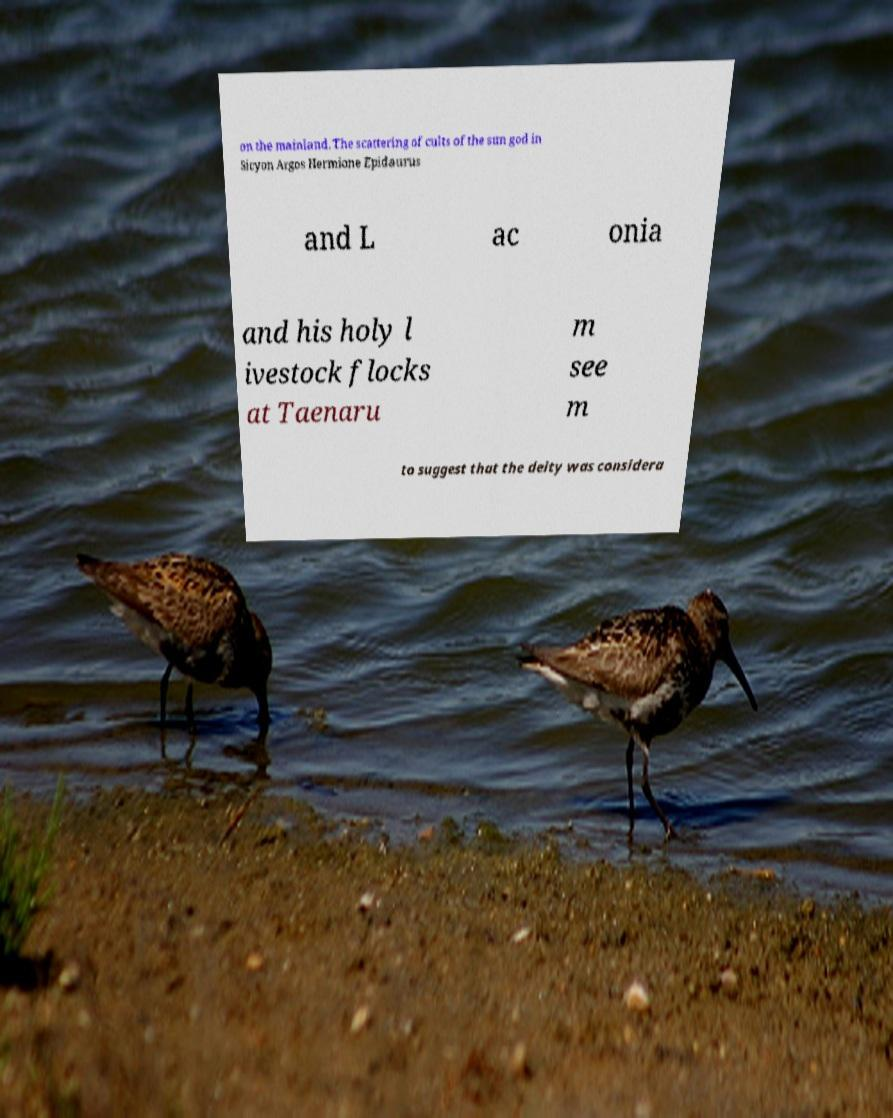Could you extract and type out the text from this image? on the mainland. The scattering of cults of the sun god in Sicyon Argos Hermione Epidaurus and L ac onia and his holy l ivestock flocks at Taenaru m see m to suggest that the deity was considera 